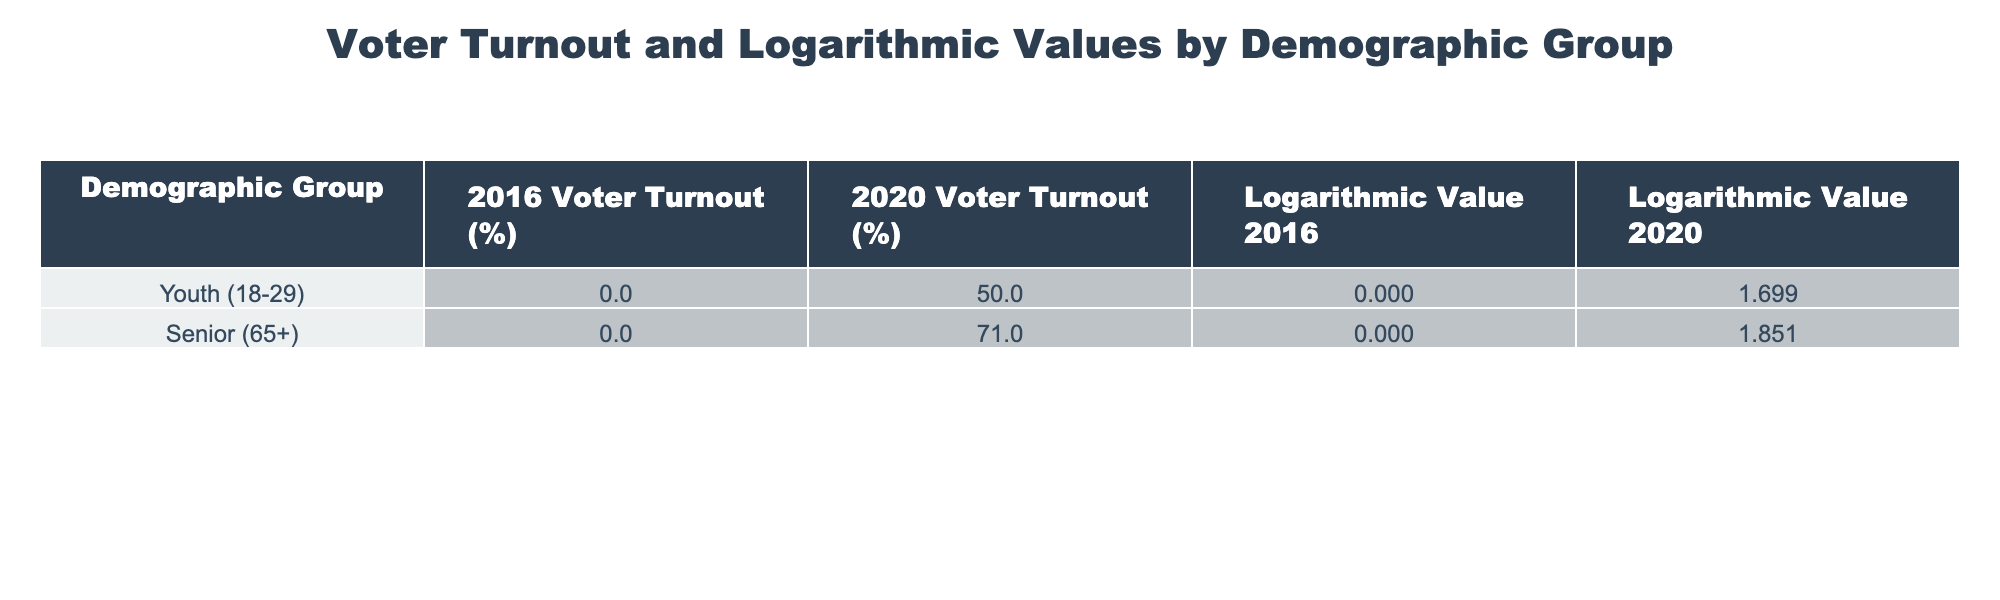What was the voter turnout percentage for seniors in 2020? According to the table, the voter turnout percentage for seniors (65+) in 2020 is stated directly under the "2020 Voter Turnout (%)" column. It shows "71.0."
Answer: 71.0 What is the logarithmic value for youth voter turnout in 2020? The table provides the logarithmic value for youth voter turnout in 2020 under the "Logarithmic Value 2020" column, which is "1.699."
Answer: 1.699 What is the difference in voter turnout percentage between youth and seniors for the year 2020? For the year 2020, youth voter turnout is 50.0% and seniors is 71.0%. The difference can be calculated as 71.0 - 50.0 = 21.0%.
Answer: 21.0% Is the voter turnout for seniors higher than that for youth in both 2016 and 2020? In 2020, seniors had a voter turnout of 71.0% compared to youth's 50.0%, which is higher. However, there is no data for the 2016 turnout for both groups, so we cannot fully answer this.
Answer: No What is the average voter turnout percentage for youth and seniors in the year 2020? The voter turnout for youth in 2020 is 50.0% and for seniors, it is 71.0%. To find the average, add both percentages (50.0 + 71.0 = 121.0) and divide by 2, resulting in an average of 60.5%.
Answer: 60.5 What is the logarithmic value difference between the two demographic groups in 2020? The logarithmic value for youth is 1.699, and for seniors, it is 1.851 in 2020. The difference can be calculated as 1.851 - 1.699 = 0.152.
Answer: 0.152 Is the voter turnout for seniors in 2020 above 70%? The table indicates that the voter turnout for seniors in 2020 is 71.0%, which is indeed above 70%.
Answer: Yes Calculate the total voter turnout percentage for both demographic groups in 2020. The total voter turnout percentage for both groups can be found by adding the turnout percentages: 50.0% (youth) + 71.0% (seniors) = 121.0%.
Answer: 121.0 